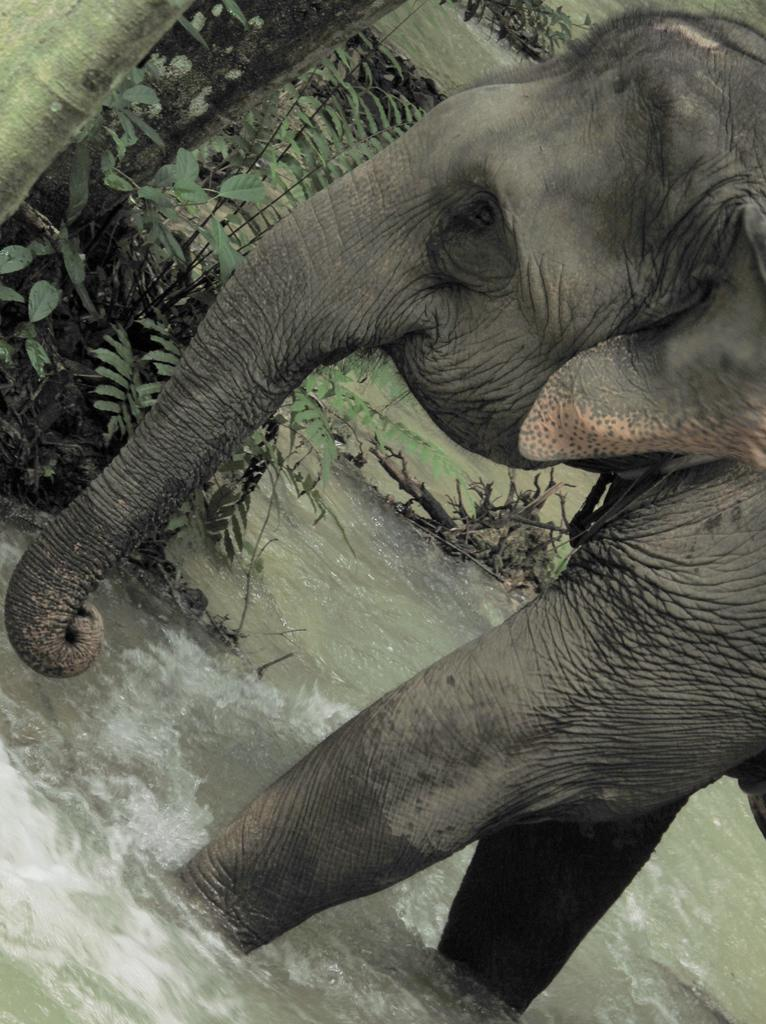What animal can be seen on the right side of the image? There is an elephant on the right side of the image. What is visible at the bottom of the image? There is water visible at the bottom of the image. What type of vegetation is present at the top of the image? There is a tree present at the top of the image. What type of cherry is being used as a decoration on the elephant's trunk in the image? There is no cherry present on the elephant's trunk in the image. 